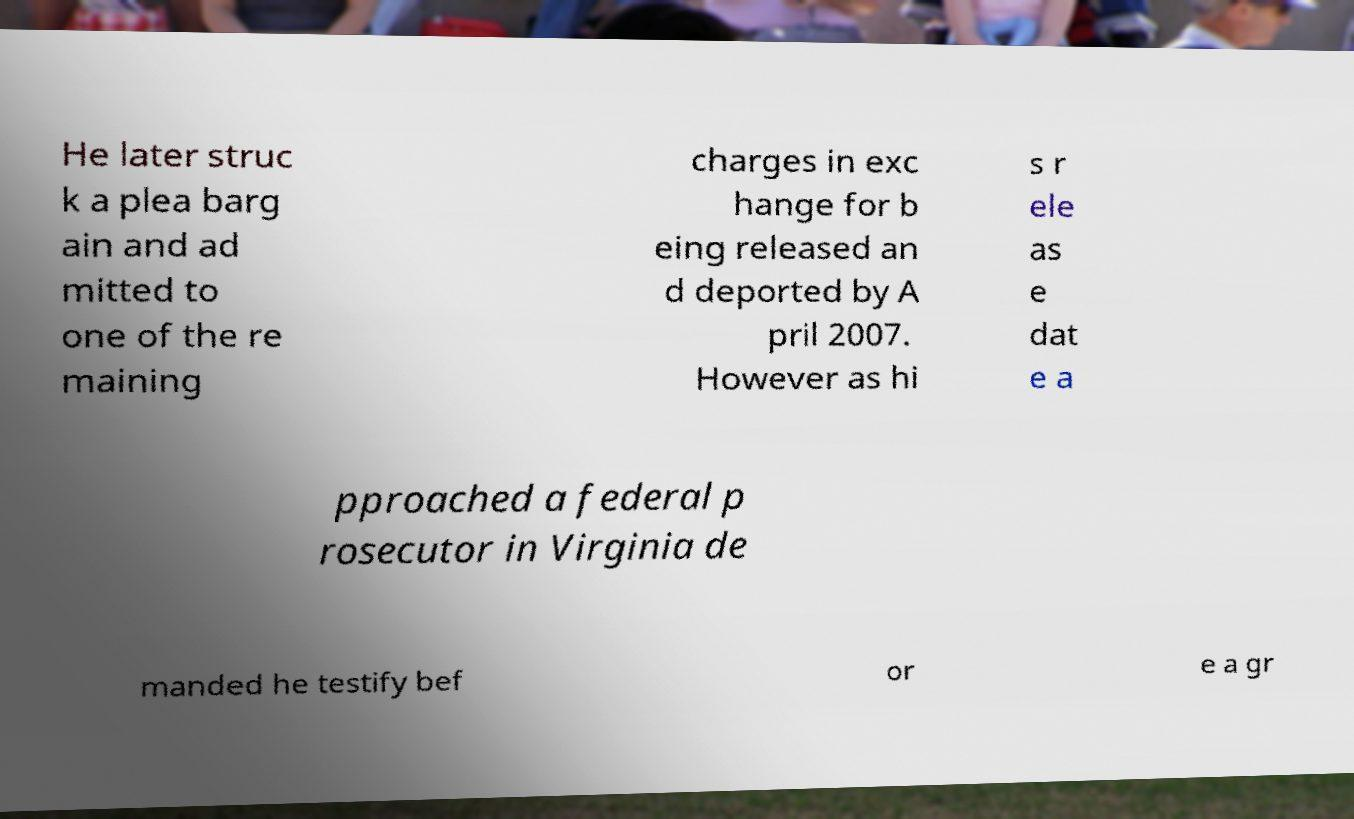Please read and relay the text visible in this image. What does it say? He later struc k a plea barg ain and ad mitted to one of the re maining charges in exc hange for b eing released an d deported by A pril 2007. However as hi s r ele as e dat e a pproached a federal p rosecutor in Virginia de manded he testify bef or e a gr 